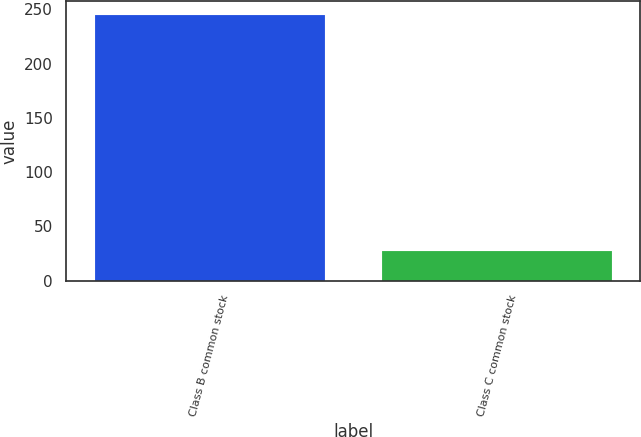Convert chart to OTSL. <chart><loc_0><loc_0><loc_500><loc_500><bar_chart><fcel>Class B common stock<fcel>Class C common stock<nl><fcel>245<fcel>27<nl></chart> 